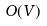Convert formula to latex. <formula><loc_0><loc_0><loc_500><loc_500>O ( V )</formula> 